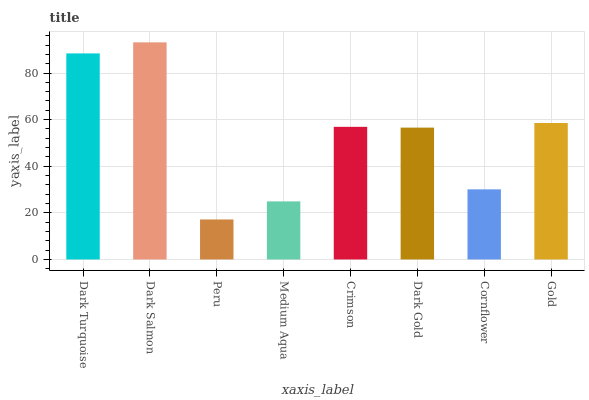Is Peru the minimum?
Answer yes or no. Yes. Is Dark Salmon the maximum?
Answer yes or no. Yes. Is Dark Salmon the minimum?
Answer yes or no. No. Is Peru the maximum?
Answer yes or no. No. Is Dark Salmon greater than Peru?
Answer yes or no. Yes. Is Peru less than Dark Salmon?
Answer yes or no. Yes. Is Peru greater than Dark Salmon?
Answer yes or no. No. Is Dark Salmon less than Peru?
Answer yes or no. No. Is Crimson the high median?
Answer yes or no. Yes. Is Dark Gold the low median?
Answer yes or no. Yes. Is Cornflower the high median?
Answer yes or no. No. Is Cornflower the low median?
Answer yes or no. No. 